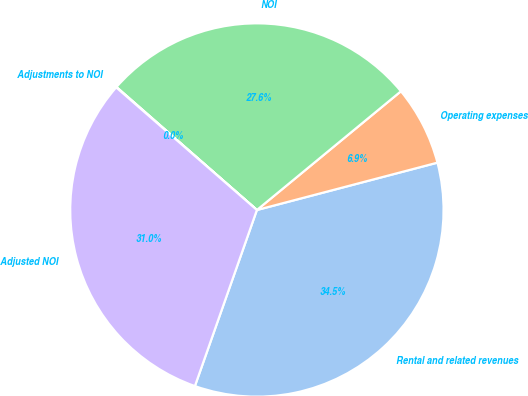<chart> <loc_0><loc_0><loc_500><loc_500><pie_chart><fcel>Rental and related revenues<fcel>Operating expenses<fcel>NOI<fcel>Adjustments to NOI<fcel>Adjusted NOI<nl><fcel>34.47%<fcel>6.89%<fcel>27.58%<fcel>0.04%<fcel>31.02%<nl></chart> 